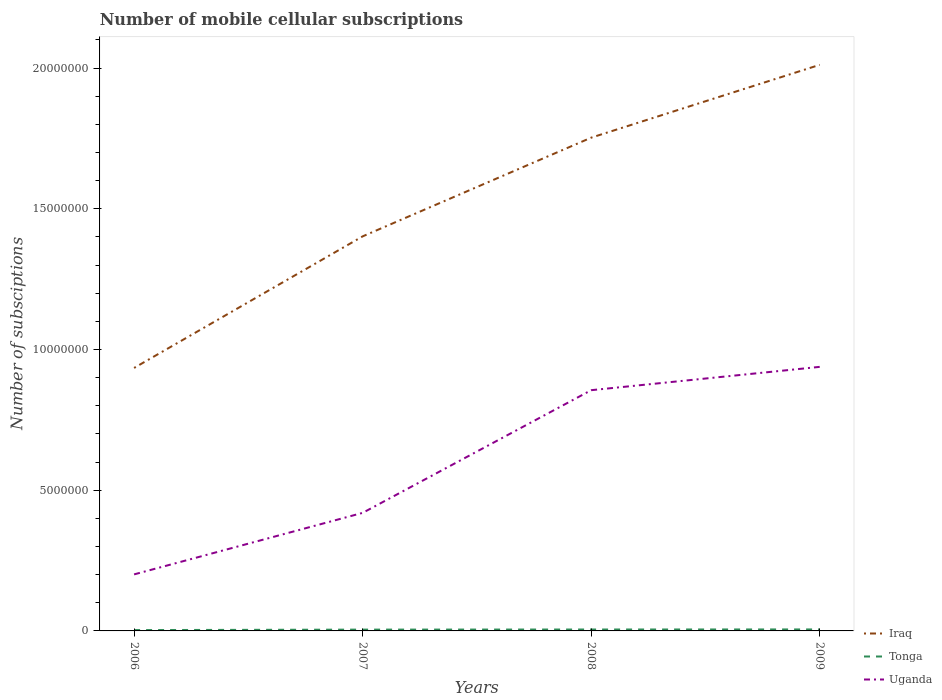Across all years, what is the maximum number of mobile cellular subscriptions in Uganda?
Offer a very short reply. 2.01e+06. What is the total number of mobile cellular subscriptions in Iraq in the graph?
Your answer should be very brief. -6.10e+06. What is the difference between the highest and the second highest number of mobile cellular subscriptions in Iraq?
Give a very brief answer. 1.08e+07. What is the difference between the highest and the lowest number of mobile cellular subscriptions in Tonga?
Provide a short and direct response. 3. How many lines are there?
Ensure brevity in your answer.  3. How many years are there in the graph?
Make the answer very short. 4. Does the graph contain grids?
Your answer should be compact. No. Where does the legend appear in the graph?
Your answer should be very brief. Bottom right. How many legend labels are there?
Provide a short and direct response. 3. How are the legend labels stacked?
Offer a terse response. Vertical. What is the title of the graph?
Provide a short and direct response. Number of mobile cellular subscriptions. What is the label or title of the Y-axis?
Provide a short and direct response. Number of subsciptions. What is the Number of subsciptions in Iraq in 2006?
Offer a very short reply. 9.35e+06. What is the Number of subsciptions of Tonga in 2006?
Provide a short and direct response. 3.01e+04. What is the Number of subsciptions in Uganda in 2006?
Your response must be concise. 2.01e+06. What is the Number of subsciptions in Iraq in 2007?
Ensure brevity in your answer.  1.40e+07. What is the Number of subsciptions of Tonga in 2007?
Give a very brief answer. 4.65e+04. What is the Number of subsciptions in Uganda in 2007?
Ensure brevity in your answer.  4.20e+06. What is the Number of subsciptions of Iraq in 2008?
Offer a very short reply. 1.75e+07. What is the Number of subsciptions in Tonga in 2008?
Your response must be concise. 5.05e+04. What is the Number of subsciptions of Uganda in 2008?
Keep it short and to the point. 8.55e+06. What is the Number of subsciptions of Iraq in 2009?
Your answer should be compact. 2.01e+07. What is the Number of subsciptions of Tonga in 2009?
Offer a very short reply. 5.30e+04. What is the Number of subsciptions in Uganda in 2009?
Ensure brevity in your answer.  9.38e+06. Across all years, what is the maximum Number of subsciptions of Iraq?
Ensure brevity in your answer.  2.01e+07. Across all years, what is the maximum Number of subsciptions in Tonga?
Give a very brief answer. 5.30e+04. Across all years, what is the maximum Number of subsciptions of Uganda?
Provide a short and direct response. 9.38e+06. Across all years, what is the minimum Number of subsciptions in Iraq?
Provide a short and direct response. 9.35e+06. Across all years, what is the minimum Number of subsciptions of Tonga?
Give a very brief answer. 3.01e+04. Across all years, what is the minimum Number of subsciptions of Uganda?
Provide a short and direct response. 2.01e+06. What is the total Number of subsciptions in Iraq in the graph?
Give a very brief answer. 6.10e+07. What is the total Number of subsciptions of Tonga in the graph?
Provide a succinct answer. 1.80e+05. What is the total Number of subsciptions of Uganda in the graph?
Your response must be concise. 2.41e+07. What is the difference between the Number of subsciptions of Iraq in 2006 and that in 2007?
Your response must be concise. -4.68e+06. What is the difference between the Number of subsciptions of Tonga in 2006 and that in 2007?
Provide a succinct answer. -1.65e+04. What is the difference between the Number of subsciptions in Uganda in 2006 and that in 2007?
Your answer should be compact. -2.19e+06. What is the difference between the Number of subsciptions of Iraq in 2006 and that in 2008?
Your answer should be very brief. -8.18e+06. What is the difference between the Number of subsciptions of Tonga in 2006 and that in 2008?
Your response must be concise. -2.04e+04. What is the difference between the Number of subsciptions of Uganda in 2006 and that in 2008?
Make the answer very short. -6.55e+06. What is the difference between the Number of subsciptions of Iraq in 2006 and that in 2009?
Provide a succinct answer. -1.08e+07. What is the difference between the Number of subsciptions in Tonga in 2006 and that in 2009?
Make the answer very short. -2.29e+04. What is the difference between the Number of subsciptions in Uganda in 2006 and that in 2009?
Ensure brevity in your answer.  -7.37e+06. What is the difference between the Number of subsciptions of Iraq in 2007 and that in 2008?
Give a very brief answer. -3.51e+06. What is the difference between the Number of subsciptions of Tonga in 2007 and that in 2008?
Offer a terse response. -3947. What is the difference between the Number of subsciptions in Uganda in 2007 and that in 2008?
Provide a succinct answer. -4.36e+06. What is the difference between the Number of subsciptions of Iraq in 2007 and that in 2009?
Ensure brevity in your answer.  -6.10e+06. What is the difference between the Number of subsciptions of Tonga in 2007 and that in 2009?
Offer a terse response. -6475. What is the difference between the Number of subsciptions of Uganda in 2007 and that in 2009?
Your answer should be compact. -5.19e+06. What is the difference between the Number of subsciptions of Iraq in 2008 and that in 2009?
Provide a succinct answer. -2.59e+06. What is the difference between the Number of subsciptions of Tonga in 2008 and that in 2009?
Provide a short and direct response. -2528. What is the difference between the Number of subsciptions in Uganda in 2008 and that in 2009?
Your response must be concise. -8.29e+05. What is the difference between the Number of subsciptions of Iraq in 2006 and the Number of subsciptions of Tonga in 2007?
Ensure brevity in your answer.  9.30e+06. What is the difference between the Number of subsciptions of Iraq in 2006 and the Number of subsciptions of Uganda in 2007?
Give a very brief answer. 5.15e+06. What is the difference between the Number of subsciptions of Tonga in 2006 and the Number of subsciptions of Uganda in 2007?
Make the answer very short. -4.17e+06. What is the difference between the Number of subsciptions in Iraq in 2006 and the Number of subsciptions in Tonga in 2008?
Offer a very short reply. 9.29e+06. What is the difference between the Number of subsciptions in Iraq in 2006 and the Number of subsciptions in Uganda in 2008?
Your response must be concise. 7.91e+05. What is the difference between the Number of subsciptions of Tonga in 2006 and the Number of subsciptions of Uganda in 2008?
Your answer should be compact. -8.52e+06. What is the difference between the Number of subsciptions of Iraq in 2006 and the Number of subsciptions of Tonga in 2009?
Provide a succinct answer. 9.29e+06. What is the difference between the Number of subsciptions in Iraq in 2006 and the Number of subsciptions in Uganda in 2009?
Your answer should be compact. -3.84e+04. What is the difference between the Number of subsciptions of Tonga in 2006 and the Number of subsciptions of Uganda in 2009?
Ensure brevity in your answer.  -9.35e+06. What is the difference between the Number of subsciptions of Iraq in 2007 and the Number of subsciptions of Tonga in 2008?
Your response must be concise. 1.40e+07. What is the difference between the Number of subsciptions in Iraq in 2007 and the Number of subsciptions in Uganda in 2008?
Provide a short and direct response. 5.47e+06. What is the difference between the Number of subsciptions in Tonga in 2007 and the Number of subsciptions in Uganda in 2008?
Your answer should be very brief. -8.51e+06. What is the difference between the Number of subsciptions in Iraq in 2007 and the Number of subsciptions in Tonga in 2009?
Offer a very short reply. 1.40e+07. What is the difference between the Number of subsciptions of Iraq in 2007 and the Number of subsciptions of Uganda in 2009?
Provide a short and direct response. 4.64e+06. What is the difference between the Number of subsciptions in Tonga in 2007 and the Number of subsciptions in Uganda in 2009?
Make the answer very short. -9.34e+06. What is the difference between the Number of subsciptions in Iraq in 2008 and the Number of subsciptions in Tonga in 2009?
Ensure brevity in your answer.  1.75e+07. What is the difference between the Number of subsciptions of Iraq in 2008 and the Number of subsciptions of Uganda in 2009?
Ensure brevity in your answer.  8.15e+06. What is the difference between the Number of subsciptions in Tonga in 2008 and the Number of subsciptions in Uganda in 2009?
Provide a succinct answer. -9.33e+06. What is the average Number of subsciptions of Iraq per year?
Your response must be concise. 1.53e+07. What is the average Number of subsciptions of Tonga per year?
Give a very brief answer. 4.50e+04. What is the average Number of subsciptions of Uganda per year?
Keep it short and to the point. 6.04e+06. In the year 2006, what is the difference between the Number of subsciptions in Iraq and Number of subsciptions in Tonga?
Offer a terse response. 9.32e+06. In the year 2006, what is the difference between the Number of subsciptions of Iraq and Number of subsciptions of Uganda?
Ensure brevity in your answer.  7.34e+06. In the year 2006, what is the difference between the Number of subsciptions in Tonga and Number of subsciptions in Uganda?
Ensure brevity in your answer.  -1.98e+06. In the year 2007, what is the difference between the Number of subsciptions in Iraq and Number of subsciptions in Tonga?
Your answer should be compact. 1.40e+07. In the year 2007, what is the difference between the Number of subsciptions in Iraq and Number of subsciptions in Uganda?
Provide a succinct answer. 9.83e+06. In the year 2007, what is the difference between the Number of subsciptions in Tonga and Number of subsciptions in Uganda?
Your answer should be compact. -4.15e+06. In the year 2008, what is the difference between the Number of subsciptions of Iraq and Number of subsciptions of Tonga?
Provide a short and direct response. 1.75e+07. In the year 2008, what is the difference between the Number of subsciptions in Iraq and Number of subsciptions in Uganda?
Provide a short and direct response. 8.97e+06. In the year 2008, what is the difference between the Number of subsciptions in Tonga and Number of subsciptions in Uganda?
Provide a succinct answer. -8.50e+06. In the year 2009, what is the difference between the Number of subsciptions in Iraq and Number of subsciptions in Tonga?
Offer a very short reply. 2.01e+07. In the year 2009, what is the difference between the Number of subsciptions of Iraq and Number of subsciptions of Uganda?
Keep it short and to the point. 1.07e+07. In the year 2009, what is the difference between the Number of subsciptions of Tonga and Number of subsciptions of Uganda?
Offer a terse response. -9.33e+06. What is the ratio of the Number of subsciptions of Iraq in 2006 to that in 2007?
Make the answer very short. 0.67. What is the ratio of the Number of subsciptions in Tonga in 2006 to that in 2007?
Offer a terse response. 0.65. What is the ratio of the Number of subsciptions of Uganda in 2006 to that in 2007?
Make the answer very short. 0.48. What is the ratio of the Number of subsciptions in Iraq in 2006 to that in 2008?
Keep it short and to the point. 0.53. What is the ratio of the Number of subsciptions in Tonga in 2006 to that in 2008?
Your answer should be compact. 0.6. What is the ratio of the Number of subsciptions in Uganda in 2006 to that in 2008?
Make the answer very short. 0.23. What is the ratio of the Number of subsciptions of Iraq in 2006 to that in 2009?
Keep it short and to the point. 0.46. What is the ratio of the Number of subsciptions in Tonga in 2006 to that in 2009?
Your response must be concise. 0.57. What is the ratio of the Number of subsciptions in Uganda in 2006 to that in 2009?
Keep it short and to the point. 0.21. What is the ratio of the Number of subsciptions of Iraq in 2007 to that in 2008?
Provide a short and direct response. 0.8. What is the ratio of the Number of subsciptions in Tonga in 2007 to that in 2008?
Provide a succinct answer. 0.92. What is the ratio of the Number of subsciptions of Uganda in 2007 to that in 2008?
Your answer should be very brief. 0.49. What is the ratio of the Number of subsciptions of Iraq in 2007 to that in 2009?
Make the answer very short. 0.7. What is the ratio of the Number of subsciptions in Tonga in 2007 to that in 2009?
Offer a very short reply. 0.88. What is the ratio of the Number of subsciptions of Uganda in 2007 to that in 2009?
Your response must be concise. 0.45. What is the ratio of the Number of subsciptions of Iraq in 2008 to that in 2009?
Ensure brevity in your answer.  0.87. What is the ratio of the Number of subsciptions of Tonga in 2008 to that in 2009?
Make the answer very short. 0.95. What is the ratio of the Number of subsciptions in Uganda in 2008 to that in 2009?
Your response must be concise. 0.91. What is the difference between the highest and the second highest Number of subsciptions of Iraq?
Keep it short and to the point. 2.59e+06. What is the difference between the highest and the second highest Number of subsciptions of Tonga?
Your answer should be compact. 2528. What is the difference between the highest and the second highest Number of subsciptions in Uganda?
Keep it short and to the point. 8.29e+05. What is the difference between the highest and the lowest Number of subsciptions in Iraq?
Keep it short and to the point. 1.08e+07. What is the difference between the highest and the lowest Number of subsciptions of Tonga?
Your response must be concise. 2.29e+04. What is the difference between the highest and the lowest Number of subsciptions in Uganda?
Keep it short and to the point. 7.37e+06. 